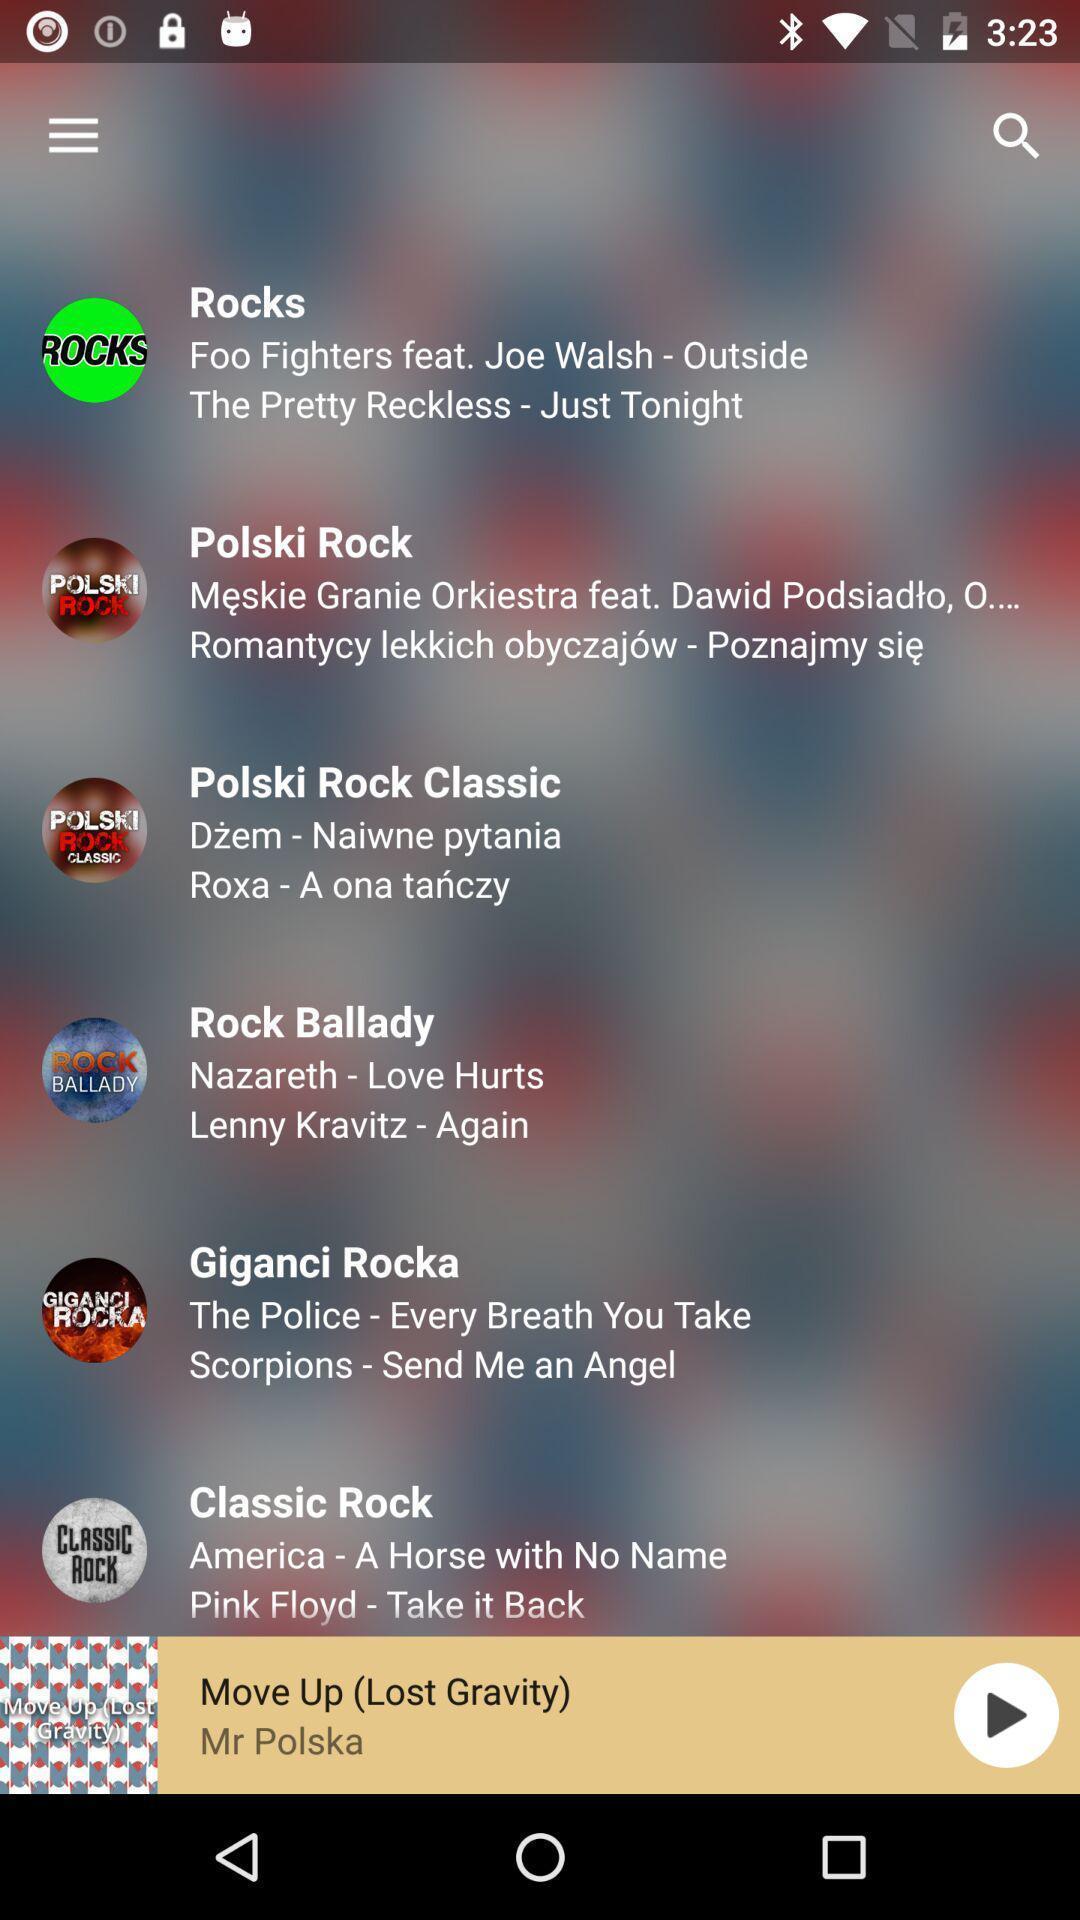Describe the key features of this screenshot. Window displaying a open fm app. 